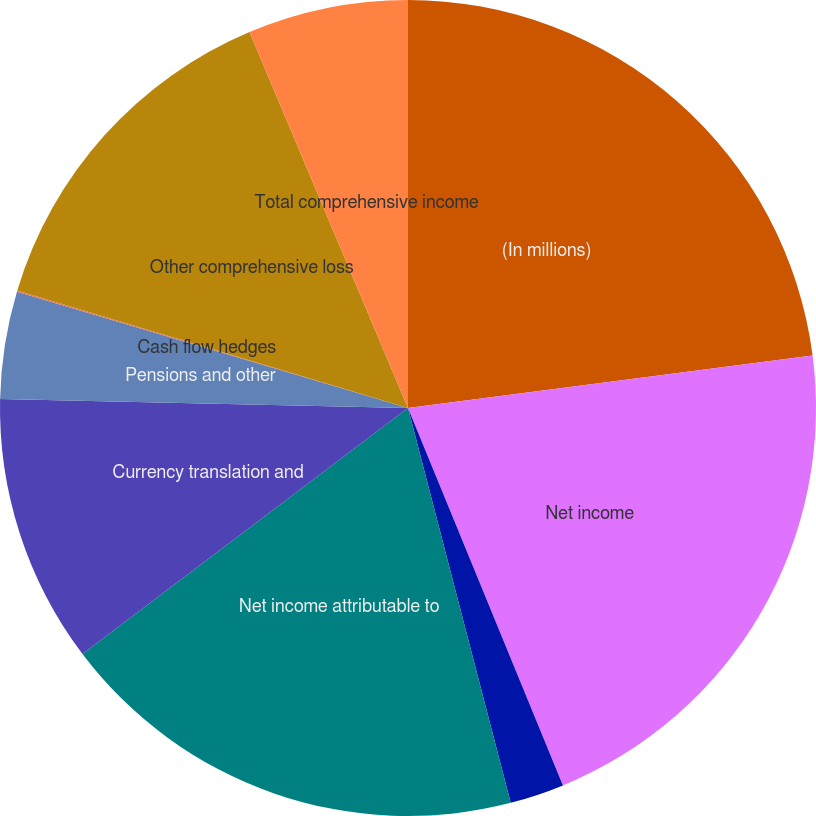<chart> <loc_0><loc_0><loc_500><loc_500><pie_chart><fcel>(In millions)<fcel>Net income<fcel>Less net income for<fcel>Net income attributable to<fcel>Currency translation and<fcel>Pensions and other<fcel>Cash flow hedges<fcel>Other comprehensive loss<fcel>Total comprehensive income<nl><fcel>22.95%<fcel>20.85%<fcel>2.15%<fcel>18.75%<fcel>10.65%<fcel>4.25%<fcel>0.05%<fcel>14.0%<fcel>6.35%<nl></chart> 